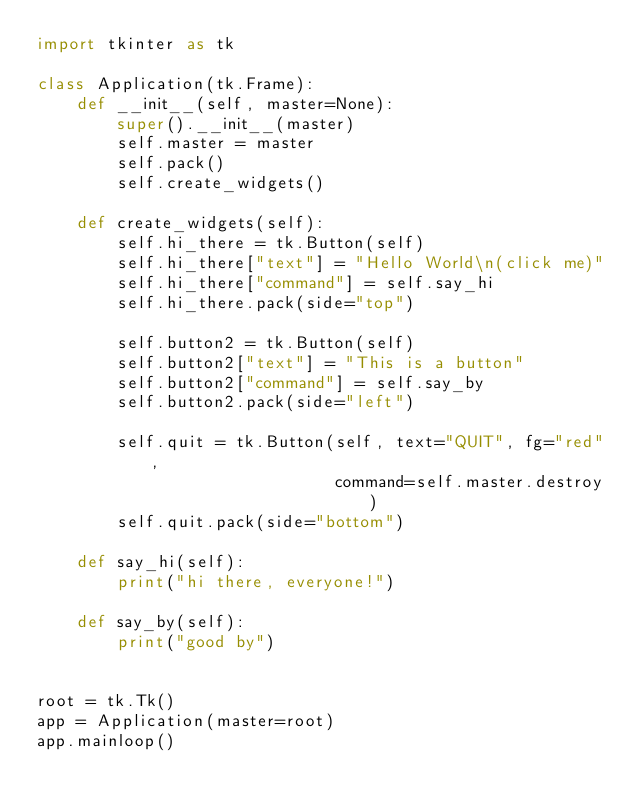Convert code to text. <code><loc_0><loc_0><loc_500><loc_500><_Python_>import tkinter as tk

class Application(tk.Frame):
    def __init__(self, master=None):
        super().__init__(master)
        self.master = master
        self.pack()
        self.create_widgets()

    def create_widgets(self):
        self.hi_there = tk.Button(self)
        self.hi_there["text"] = "Hello World\n(click me)"
        self.hi_there["command"] = self.say_hi
        self.hi_there.pack(side="top")

        self.button2 = tk.Button(self)
        self.button2["text"] = "This is a button"
        self.button2["command"] = self.say_by
        self.button2.pack(side="left")

        self.quit = tk.Button(self, text="QUIT", fg="red",
                              command=self.master.destroy)
        self.quit.pack(side="bottom")

    def say_hi(self):
        print("hi there, everyone!")

    def say_by(self):
        print("good by")


root = tk.Tk()
app = Application(master=root)
app.mainloop()</code> 